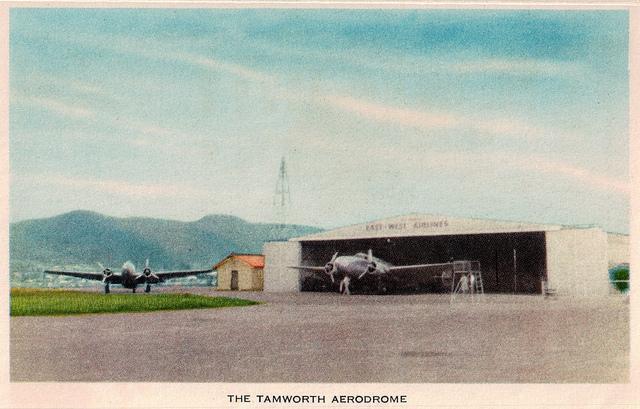Where is the silver plane on the right being stored?
Indicate the correct response and explain using: 'Answer: answer
Rationale: rationale.'
Options: Home, hotel, hanger, shed. Answer: hanger.
Rationale: The plane is in a large garage type area. 